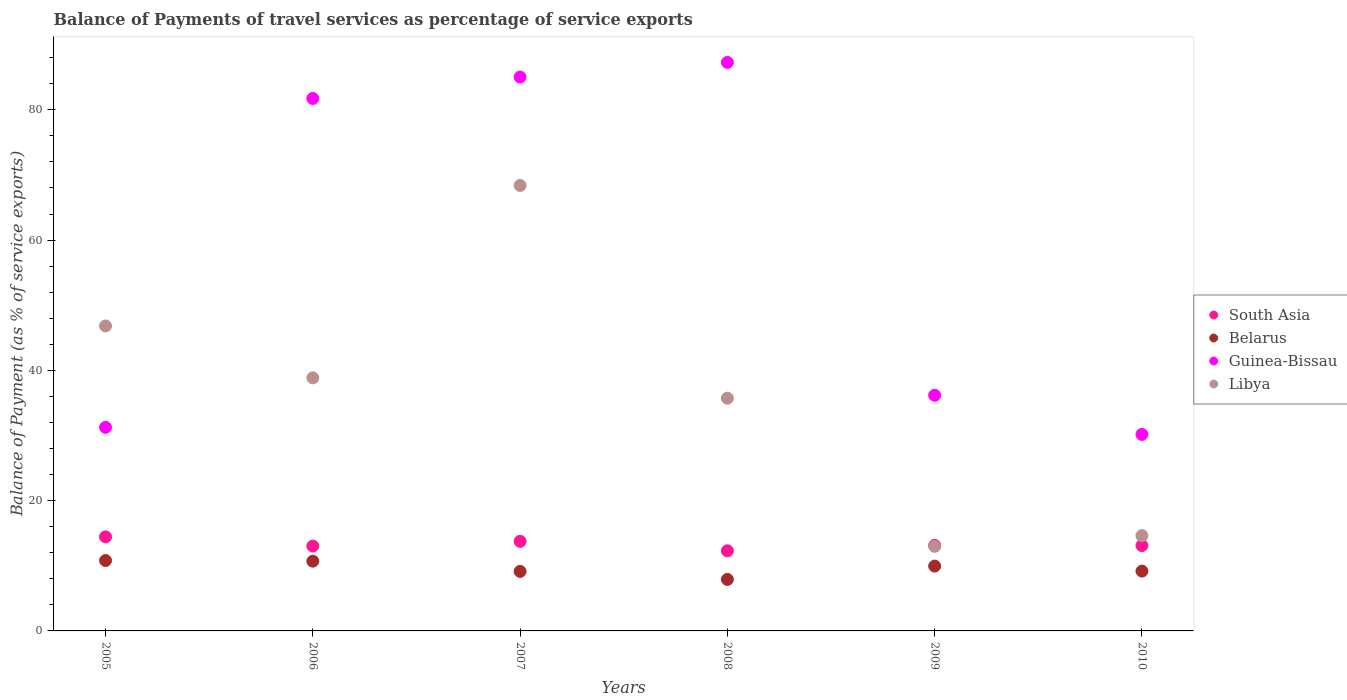What is the balance of payments of travel services in Guinea-Bissau in 2009?
Make the answer very short. 36.17. Across all years, what is the maximum balance of payments of travel services in Belarus?
Your answer should be very brief. 10.81. Across all years, what is the minimum balance of payments of travel services in Guinea-Bissau?
Ensure brevity in your answer.  30.17. In which year was the balance of payments of travel services in Libya minimum?
Ensure brevity in your answer.  2009. What is the total balance of payments of travel services in Libya in the graph?
Offer a terse response. 217.4. What is the difference between the balance of payments of travel services in Libya in 2007 and that in 2008?
Make the answer very short. 32.66. What is the difference between the balance of payments of travel services in South Asia in 2006 and the balance of payments of travel services in Belarus in 2008?
Provide a short and direct response. 5.12. What is the average balance of payments of travel services in Belarus per year?
Ensure brevity in your answer.  9.62. In the year 2006, what is the difference between the balance of payments of travel services in Libya and balance of payments of travel services in Belarus?
Your answer should be compact. 28.15. In how many years, is the balance of payments of travel services in South Asia greater than 44 %?
Your answer should be compact. 0. What is the ratio of the balance of payments of travel services in Libya in 2006 to that in 2009?
Offer a very short reply. 2.99. Is the difference between the balance of payments of travel services in Libya in 2007 and 2009 greater than the difference between the balance of payments of travel services in Belarus in 2007 and 2009?
Your response must be concise. Yes. What is the difference between the highest and the second highest balance of payments of travel services in Guinea-Bissau?
Offer a terse response. 2.25. What is the difference between the highest and the lowest balance of payments of travel services in South Asia?
Your answer should be compact. 2.14. Is the sum of the balance of payments of travel services in Libya in 2006 and 2010 greater than the maximum balance of payments of travel services in Belarus across all years?
Offer a very short reply. Yes. Is it the case that in every year, the sum of the balance of payments of travel services in Guinea-Bissau and balance of payments of travel services in South Asia  is greater than the sum of balance of payments of travel services in Libya and balance of payments of travel services in Belarus?
Provide a succinct answer. Yes. Is it the case that in every year, the sum of the balance of payments of travel services in Libya and balance of payments of travel services in South Asia  is greater than the balance of payments of travel services in Guinea-Bissau?
Your answer should be compact. No. Is the balance of payments of travel services in South Asia strictly less than the balance of payments of travel services in Belarus over the years?
Give a very brief answer. No. How many dotlines are there?
Make the answer very short. 4. How many years are there in the graph?
Make the answer very short. 6. Are the values on the major ticks of Y-axis written in scientific E-notation?
Offer a terse response. No. Does the graph contain any zero values?
Your answer should be compact. No. Does the graph contain grids?
Ensure brevity in your answer.  No. How many legend labels are there?
Offer a very short reply. 4. How are the legend labels stacked?
Your response must be concise. Vertical. What is the title of the graph?
Give a very brief answer. Balance of Payments of travel services as percentage of service exports. What is the label or title of the Y-axis?
Ensure brevity in your answer.  Balance of Payment (as % of service exports). What is the Balance of Payment (as % of service exports) of South Asia in 2005?
Provide a short and direct response. 14.44. What is the Balance of Payment (as % of service exports) of Belarus in 2005?
Offer a terse response. 10.81. What is the Balance of Payment (as % of service exports) in Guinea-Bissau in 2005?
Give a very brief answer. 31.25. What is the Balance of Payment (as % of service exports) of Libya in 2005?
Ensure brevity in your answer.  46.82. What is the Balance of Payment (as % of service exports) in South Asia in 2006?
Ensure brevity in your answer.  13.03. What is the Balance of Payment (as % of service exports) of Belarus in 2006?
Your response must be concise. 10.71. What is the Balance of Payment (as % of service exports) in Guinea-Bissau in 2006?
Provide a succinct answer. 81.74. What is the Balance of Payment (as % of service exports) of Libya in 2006?
Provide a short and direct response. 38.85. What is the Balance of Payment (as % of service exports) in South Asia in 2007?
Your answer should be very brief. 13.75. What is the Balance of Payment (as % of service exports) in Belarus in 2007?
Offer a terse response. 9.14. What is the Balance of Payment (as % of service exports) of Guinea-Bissau in 2007?
Make the answer very short. 85.03. What is the Balance of Payment (as % of service exports) in Libya in 2007?
Your answer should be compact. 68.39. What is the Balance of Payment (as % of service exports) of South Asia in 2008?
Provide a short and direct response. 12.3. What is the Balance of Payment (as % of service exports) of Belarus in 2008?
Offer a terse response. 7.91. What is the Balance of Payment (as % of service exports) of Guinea-Bissau in 2008?
Offer a very short reply. 87.27. What is the Balance of Payment (as % of service exports) of Libya in 2008?
Ensure brevity in your answer.  35.72. What is the Balance of Payment (as % of service exports) in South Asia in 2009?
Offer a very short reply. 13.14. What is the Balance of Payment (as % of service exports) in Belarus in 2009?
Your answer should be very brief. 9.95. What is the Balance of Payment (as % of service exports) of Guinea-Bissau in 2009?
Give a very brief answer. 36.17. What is the Balance of Payment (as % of service exports) of Libya in 2009?
Keep it short and to the point. 12.99. What is the Balance of Payment (as % of service exports) of South Asia in 2010?
Provide a succinct answer. 13.11. What is the Balance of Payment (as % of service exports) in Belarus in 2010?
Provide a short and direct response. 9.18. What is the Balance of Payment (as % of service exports) of Guinea-Bissau in 2010?
Ensure brevity in your answer.  30.17. What is the Balance of Payment (as % of service exports) of Libya in 2010?
Give a very brief answer. 14.63. Across all years, what is the maximum Balance of Payment (as % of service exports) in South Asia?
Make the answer very short. 14.44. Across all years, what is the maximum Balance of Payment (as % of service exports) in Belarus?
Make the answer very short. 10.81. Across all years, what is the maximum Balance of Payment (as % of service exports) of Guinea-Bissau?
Offer a very short reply. 87.27. Across all years, what is the maximum Balance of Payment (as % of service exports) of Libya?
Offer a terse response. 68.39. Across all years, what is the minimum Balance of Payment (as % of service exports) in South Asia?
Provide a short and direct response. 12.3. Across all years, what is the minimum Balance of Payment (as % of service exports) in Belarus?
Offer a terse response. 7.91. Across all years, what is the minimum Balance of Payment (as % of service exports) in Guinea-Bissau?
Offer a very short reply. 30.17. Across all years, what is the minimum Balance of Payment (as % of service exports) in Libya?
Ensure brevity in your answer.  12.99. What is the total Balance of Payment (as % of service exports) in South Asia in the graph?
Provide a succinct answer. 79.76. What is the total Balance of Payment (as % of service exports) of Belarus in the graph?
Offer a very short reply. 57.7. What is the total Balance of Payment (as % of service exports) of Guinea-Bissau in the graph?
Your answer should be very brief. 351.63. What is the total Balance of Payment (as % of service exports) of Libya in the graph?
Provide a succinct answer. 217.4. What is the difference between the Balance of Payment (as % of service exports) in South Asia in 2005 and that in 2006?
Your answer should be very brief. 1.41. What is the difference between the Balance of Payment (as % of service exports) of Belarus in 2005 and that in 2006?
Offer a terse response. 0.1. What is the difference between the Balance of Payment (as % of service exports) of Guinea-Bissau in 2005 and that in 2006?
Ensure brevity in your answer.  -50.49. What is the difference between the Balance of Payment (as % of service exports) of Libya in 2005 and that in 2006?
Your response must be concise. 7.96. What is the difference between the Balance of Payment (as % of service exports) of South Asia in 2005 and that in 2007?
Offer a very short reply. 0.69. What is the difference between the Balance of Payment (as % of service exports) of Belarus in 2005 and that in 2007?
Give a very brief answer. 1.67. What is the difference between the Balance of Payment (as % of service exports) in Guinea-Bissau in 2005 and that in 2007?
Provide a succinct answer. -53.77. What is the difference between the Balance of Payment (as % of service exports) of Libya in 2005 and that in 2007?
Offer a terse response. -21.57. What is the difference between the Balance of Payment (as % of service exports) in South Asia in 2005 and that in 2008?
Offer a very short reply. 2.14. What is the difference between the Balance of Payment (as % of service exports) in Belarus in 2005 and that in 2008?
Give a very brief answer. 2.9. What is the difference between the Balance of Payment (as % of service exports) in Guinea-Bissau in 2005 and that in 2008?
Give a very brief answer. -56.02. What is the difference between the Balance of Payment (as % of service exports) of Libya in 2005 and that in 2008?
Make the answer very short. 11.09. What is the difference between the Balance of Payment (as % of service exports) in South Asia in 2005 and that in 2009?
Make the answer very short. 1.3. What is the difference between the Balance of Payment (as % of service exports) in Belarus in 2005 and that in 2009?
Ensure brevity in your answer.  0.85. What is the difference between the Balance of Payment (as % of service exports) of Guinea-Bissau in 2005 and that in 2009?
Ensure brevity in your answer.  -4.92. What is the difference between the Balance of Payment (as % of service exports) in Libya in 2005 and that in 2009?
Your response must be concise. 33.83. What is the difference between the Balance of Payment (as % of service exports) of South Asia in 2005 and that in 2010?
Offer a terse response. 1.33. What is the difference between the Balance of Payment (as % of service exports) of Belarus in 2005 and that in 2010?
Your response must be concise. 1.62. What is the difference between the Balance of Payment (as % of service exports) in Guinea-Bissau in 2005 and that in 2010?
Ensure brevity in your answer.  1.09. What is the difference between the Balance of Payment (as % of service exports) in Libya in 2005 and that in 2010?
Ensure brevity in your answer.  32.19. What is the difference between the Balance of Payment (as % of service exports) of South Asia in 2006 and that in 2007?
Your answer should be compact. -0.72. What is the difference between the Balance of Payment (as % of service exports) in Belarus in 2006 and that in 2007?
Offer a terse response. 1.57. What is the difference between the Balance of Payment (as % of service exports) of Guinea-Bissau in 2006 and that in 2007?
Give a very brief answer. -3.28. What is the difference between the Balance of Payment (as % of service exports) of Libya in 2006 and that in 2007?
Your answer should be compact. -29.53. What is the difference between the Balance of Payment (as % of service exports) in South Asia in 2006 and that in 2008?
Your answer should be compact. 0.73. What is the difference between the Balance of Payment (as % of service exports) of Belarus in 2006 and that in 2008?
Your answer should be very brief. 2.8. What is the difference between the Balance of Payment (as % of service exports) of Guinea-Bissau in 2006 and that in 2008?
Make the answer very short. -5.53. What is the difference between the Balance of Payment (as % of service exports) in Libya in 2006 and that in 2008?
Offer a very short reply. 3.13. What is the difference between the Balance of Payment (as % of service exports) of South Asia in 2006 and that in 2009?
Give a very brief answer. -0.11. What is the difference between the Balance of Payment (as % of service exports) of Belarus in 2006 and that in 2009?
Ensure brevity in your answer.  0.75. What is the difference between the Balance of Payment (as % of service exports) in Guinea-Bissau in 2006 and that in 2009?
Your answer should be very brief. 45.57. What is the difference between the Balance of Payment (as % of service exports) in Libya in 2006 and that in 2009?
Your answer should be compact. 25.87. What is the difference between the Balance of Payment (as % of service exports) of South Asia in 2006 and that in 2010?
Offer a very short reply. -0.08. What is the difference between the Balance of Payment (as % of service exports) of Belarus in 2006 and that in 2010?
Keep it short and to the point. 1.53. What is the difference between the Balance of Payment (as % of service exports) of Guinea-Bissau in 2006 and that in 2010?
Offer a terse response. 51.58. What is the difference between the Balance of Payment (as % of service exports) of Libya in 2006 and that in 2010?
Your answer should be very brief. 24.22. What is the difference between the Balance of Payment (as % of service exports) of South Asia in 2007 and that in 2008?
Provide a short and direct response. 1.45. What is the difference between the Balance of Payment (as % of service exports) in Belarus in 2007 and that in 2008?
Make the answer very short. 1.23. What is the difference between the Balance of Payment (as % of service exports) of Guinea-Bissau in 2007 and that in 2008?
Ensure brevity in your answer.  -2.25. What is the difference between the Balance of Payment (as % of service exports) of Libya in 2007 and that in 2008?
Your answer should be very brief. 32.66. What is the difference between the Balance of Payment (as % of service exports) in South Asia in 2007 and that in 2009?
Keep it short and to the point. 0.61. What is the difference between the Balance of Payment (as % of service exports) of Belarus in 2007 and that in 2009?
Your response must be concise. -0.82. What is the difference between the Balance of Payment (as % of service exports) of Guinea-Bissau in 2007 and that in 2009?
Your response must be concise. 48.85. What is the difference between the Balance of Payment (as % of service exports) in Libya in 2007 and that in 2009?
Your answer should be compact. 55.4. What is the difference between the Balance of Payment (as % of service exports) in South Asia in 2007 and that in 2010?
Provide a succinct answer. 0.64. What is the difference between the Balance of Payment (as % of service exports) in Belarus in 2007 and that in 2010?
Your response must be concise. -0.05. What is the difference between the Balance of Payment (as % of service exports) in Guinea-Bissau in 2007 and that in 2010?
Offer a terse response. 54.86. What is the difference between the Balance of Payment (as % of service exports) of Libya in 2007 and that in 2010?
Ensure brevity in your answer.  53.76. What is the difference between the Balance of Payment (as % of service exports) in South Asia in 2008 and that in 2009?
Your answer should be compact. -0.84. What is the difference between the Balance of Payment (as % of service exports) of Belarus in 2008 and that in 2009?
Your response must be concise. -2.05. What is the difference between the Balance of Payment (as % of service exports) in Guinea-Bissau in 2008 and that in 2009?
Your response must be concise. 51.1. What is the difference between the Balance of Payment (as % of service exports) of Libya in 2008 and that in 2009?
Make the answer very short. 22.74. What is the difference between the Balance of Payment (as % of service exports) of South Asia in 2008 and that in 2010?
Your response must be concise. -0.81. What is the difference between the Balance of Payment (as % of service exports) of Belarus in 2008 and that in 2010?
Offer a very short reply. -1.28. What is the difference between the Balance of Payment (as % of service exports) of Guinea-Bissau in 2008 and that in 2010?
Provide a short and direct response. 57.11. What is the difference between the Balance of Payment (as % of service exports) in Libya in 2008 and that in 2010?
Keep it short and to the point. 21.09. What is the difference between the Balance of Payment (as % of service exports) of South Asia in 2009 and that in 2010?
Offer a terse response. 0.04. What is the difference between the Balance of Payment (as % of service exports) in Belarus in 2009 and that in 2010?
Offer a very short reply. 0.77. What is the difference between the Balance of Payment (as % of service exports) of Guinea-Bissau in 2009 and that in 2010?
Ensure brevity in your answer.  6.01. What is the difference between the Balance of Payment (as % of service exports) of Libya in 2009 and that in 2010?
Your response must be concise. -1.64. What is the difference between the Balance of Payment (as % of service exports) of South Asia in 2005 and the Balance of Payment (as % of service exports) of Belarus in 2006?
Your answer should be compact. 3.73. What is the difference between the Balance of Payment (as % of service exports) in South Asia in 2005 and the Balance of Payment (as % of service exports) in Guinea-Bissau in 2006?
Your answer should be compact. -67.3. What is the difference between the Balance of Payment (as % of service exports) of South Asia in 2005 and the Balance of Payment (as % of service exports) of Libya in 2006?
Provide a short and direct response. -24.42. What is the difference between the Balance of Payment (as % of service exports) in Belarus in 2005 and the Balance of Payment (as % of service exports) in Guinea-Bissau in 2006?
Offer a very short reply. -70.94. What is the difference between the Balance of Payment (as % of service exports) in Belarus in 2005 and the Balance of Payment (as % of service exports) in Libya in 2006?
Offer a very short reply. -28.05. What is the difference between the Balance of Payment (as % of service exports) of Guinea-Bissau in 2005 and the Balance of Payment (as % of service exports) of Libya in 2006?
Offer a terse response. -7.6. What is the difference between the Balance of Payment (as % of service exports) of South Asia in 2005 and the Balance of Payment (as % of service exports) of Belarus in 2007?
Provide a succinct answer. 5.3. What is the difference between the Balance of Payment (as % of service exports) of South Asia in 2005 and the Balance of Payment (as % of service exports) of Guinea-Bissau in 2007?
Make the answer very short. -70.59. What is the difference between the Balance of Payment (as % of service exports) of South Asia in 2005 and the Balance of Payment (as % of service exports) of Libya in 2007?
Offer a terse response. -53.95. What is the difference between the Balance of Payment (as % of service exports) in Belarus in 2005 and the Balance of Payment (as % of service exports) in Guinea-Bissau in 2007?
Offer a terse response. -74.22. What is the difference between the Balance of Payment (as % of service exports) in Belarus in 2005 and the Balance of Payment (as % of service exports) in Libya in 2007?
Keep it short and to the point. -57.58. What is the difference between the Balance of Payment (as % of service exports) in Guinea-Bissau in 2005 and the Balance of Payment (as % of service exports) in Libya in 2007?
Provide a short and direct response. -37.13. What is the difference between the Balance of Payment (as % of service exports) in South Asia in 2005 and the Balance of Payment (as % of service exports) in Belarus in 2008?
Offer a terse response. 6.53. What is the difference between the Balance of Payment (as % of service exports) in South Asia in 2005 and the Balance of Payment (as % of service exports) in Guinea-Bissau in 2008?
Offer a terse response. -72.84. What is the difference between the Balance of Payment (as % of service exports) of South Asia in 2005 and the Balance of Payment (as % of service exports) of Libya in 2008?
Offer a terse response. -21.29. What is the difference between the Balance of Payment (as % of service exports) of Belarus in 2005 and the Balance of Payment (as % of service exports) of Guinea-Bissau in 2008?
Your answer should be very brief. -76.47. What is the difference between the Balance of Payment (as % of service exports) in Belarus in 2005 and the Balance of Payment (as % of service exports) in Libya in 2008?
Offer a terse response. -24.92. What is the difference between the Balance of Payment (as % of service exports) of Guinea-Bissau in 2005 and the Balance of Payment (as % of service exports) of Libya in 2008?
Provide a short and direct response. -4.47. What is the difference between the Balance of Payment (as % of service exports) of South Asia in 2005 and the Balance of Payment (as % of service exports) of Belarus in 2009?
Keep it short and to the point. 4.48. What is the difference between the Balance of Payment (as % of service exports) in South Asia in 2005 and the Balance of Payment (as % of service exports) in Guinea-Bissau in 2009?
Your response must be concise. -21.73. What is the difference between the Balance of Payment (as % of service exports) in South Asia in 2005 and the Balance of Payment (as % of service exports) in Libya in 2009?
Offer a very short reply. 1.45. What is the difference between the Balance of Payment (as % of service exports) in Belarus in 2005 and the Balance of Payment (as % of service exports) in Guinea-Bissau in 2009?
Your response must be concise. -25.37. What is the difference between the Balance of Payment (as % of service exports) of Belarus in 2005 and the Balance of Payment (as % of service exports) of Libya in 2009?
Give a very brief answer. -2.18. What is the difference between the Balance of Payment (as % of service exports) of Guinea-Bissau in 2005 and the Balance of Payment (as % of service exports) of Libya in 2009?
Provide a succinct answer. 18.27. What is the difference between the Balance of Payment (as % of service exports) in South Asia in 2005 and the Balance of Payment (as % of service exports) in Belarus in 2010?
Offer a terse response. 5.25. What is the difference between the Balance of Payment (as % of service exports) in South Asia in 2005 and the Balance of Payment (as % of service exports) in Guinea-Bissau in 2010?
Give a very brief answer. -15.73. What is the difference between the Balance of Payment (as % of service exports) in South Asia in 2005 and the Balance of Payment (as % of service exports) in Libya in 2010?
Provide a short and direct response. -0.19. What is the difference between the Balance of Payment (as % of service exports) in Belarus in 2005 and the Balance of Payment (as % of service exports) in Guinea-Bissau in 2010?
Give a very brief answer. -19.36. What is the difference between the Balance of Payment (as % of service exports) of Belarus in 2005 and the Balance of Payment (as % of service exports) of Libya in 2010?
Your response must be concise. -3.83. What is the difference between the Balance of Payment (as % of service exports) in Guinea-Bissau in 2005 and the Balance of Payment (as % of service exports) in Libya in 2010?
Provide a succinct answer. 16.62. What is the difference between the Balance of Payment (as % of service exports) in South Asia in 2006 and the Balance of Payment (as % of service exports) in Belarus in 2007?
Your answer should be very brief. 3.89. What is the difference between the Balance of Payment (as % of service exports) in South Asia in 2006 and the Balance of Payment (as % of service exports) in Guinea-Bissau in 2007?
Offer a terse response. -72. What is the difference between the Balance of Payment (as % of service exports) of South Asia in 2006 and the Balance of Payment (as % of service exports) of Libya in 2007?
Offer a terse response. -55.36. What is the difference between the Balance of Payment (as % of service exports) in Belarus in 2006 and the Balance of Payment (as % of service exports) in Guinea-Bissau in 2007?
Offer a very short reply. -74.32. What is the difference between the Balance of Payment (as % of service exports) in Belarus in 2006 and the Balance of Payment (as % of service exports) in Libya in 2007?
Offer a very short reply. -57.68. What is the difference between the Balance of Payment (as % of service exports) in Guinea-Bissau in 2006 and the Balance of Payment (as % of service exports) in Libya in 2007?
Provide a short and direct response. 13.35. What is the difference between the Balance of Payment (as % of service exports) in South Asia in 2006 and the Balance of Payment (as % of service exports) in Belarus in 2008?
Make the answer very short. 5.12. What is the difference between the Balance of Payment (as % of service exports) in South Asia in 2006 and the Balance of Payment (as % of service exports) in Guinea-Bissau in 2008?
Make the answer very short. -74.25. What is the difference between the Balance of Payment (as % of service exports) of South Asia in 2006 and the Balance of Payment (as % of service exports) of Libya in 2008?
Provide a succinct answer. -22.7. What is the difference between the Balance of Payment (as % of service exports) of Belarus in 2006 and the Balance of Payment (as % of service exports) of Guinea-Bissau in 2008?
Ensure brevity in your answer.  -76.57. What is the difference between the Balance of Payment (as % of service exports) of Belarus in 2006 and the Balance of Payment (as % of service exports) of Libya in 2008?
Keep it short and to the point. -25.02. What is the difference between the Balance of Payment (as % of service exports) in Guinea-Bissau in 2006 and the Balance of Payment (as % of service exports) in Libya in 2008?
Offer a terse response. 46.02. What is the difference between the Balance of Payment (as % of service exports) of South Asia in 2006 and the Balance of Payment (as % of service exports) of Belarus in 2009?
Your answer should be compact. 3.07. What is the difference between the Balance of Payment (as % of service exports) in South Asia in 2006 and the Balance of Payment (as % of service exports) in Guinea-Bissau in 2009?
Your answer should be compact. -23.14. What is the difference between the Balance of Payment (as % of service exports) in South Asia in 2006 and the Balance of Payment (as % of service exports) in Libya in 2009?
Keep it short and to the point. 0.04. What is the difference between the Balance of Payment (as % of service exports) of Belarus in 2006 and the Balance of Payment (as % of service exports) of Guinea-Bissau in 2009?
Keep it short and to the point. -25.46. What is the difference between the Balance of Payment (as % of service exports) of Belarus in 2006 and the Balance of Payment (as % of service exports) of Libya in 2009?
Your answer should be very brief. -2.28. What is the difference between the Balance of Payment (as % of service exports) in Guinea-Bissau in 2006 and the Balance of Payment (as % of service exports) in Libya in 2009?
Your response must be concise. 68.75. What is the difference between the Balance of Payment (as % of service exports) of South Asia in 2006 and the Balance of Payment (as % of service exports) of Belarus in 2010?
Your answer should be very brief. 3.84. What is the difference between the Balance of Payment (as % of service exports) of South Asia in 2006 and the Balance of Payment (as % of service exports) of Guinea-Bissau in 2010?
Your answer should be compact. -17.14. What is the difference between the Balance of Payment (as % of service exports) of South Asia in 2006 and the Balance of Payment (as % of service exports) of Libya in 2010?
Give a very brief answer. -1.6. What is the difference between the Balance of Payment (as % of service exports) in Belarus in 2006 and the Balance of Payment (as % of service exports) in Guinea-Bissau in 2010?
Make the answer very short. -19.46. What is the difference between the Balance of Payment (as % of service exports) of Belarus in 2006 and the Balance of Payment (as % of service exports) of Libya in 2010?
Your answer should be compact. -3.92. What is the difference between the Balance of Payment (as % of service exports) of Guinea-Bissau in 2006 and the Balance of Payment (as % of service exports) of Libya in 2010?
Your answer should be compact. 67.11. What is the difference between the Balance of Payment (as % of service exports) of South Asia in 2007 and the Balance of Payment (as % of service exports) of Belarus in 2008?
Your response must be concise. 5.84. What is the difference between the Balance of Payment (as % of service exports) in South Asia in 2007 and the Balance of Payment (as % of service exports) in Guinea-Bissau in 2008?
Offer a very short reply. -73.52. What is the difference between the Balance of Payment (as % of service exports) of South Asia in 2007 and the Balance of Payment (as % of service exports) of Libya in 2008?
Give a very brief answer. -21.97. What is the difference between the Balance of Payment (as % of service exports) in Belarus in 2007 and the Balance of Payment (as % of service exports) in Guinea-Bissau in 2008?
Your answer should be compact. -78.14. What is the difference between the Balance of Payment (as % of service exports) in Belarus in 2007 and the Balance of Payment (as % of service exports) in Libya in 2008?
Ensure brevity in your answer.  -26.59. What is the difference between the Balance of Payment (as % of service exports) in Guinea-Bissau in 2007 and the Balance of Payment (as % of service exports) in Libya in 2008?
Offer a terse response. 49.3. What is the difference between the Balance of Payment (as % of service exports) in South Asia in 2007 and the Balance of Payment (as % of service exports) in Belarus in 2009?
Provide a short and direct response. 3.8. What is the difference between the Balance of Payment (as % of service exports) in South Asia in 2007 and the Balance of Payment (as % of service exports) in Guinea-Bissau in 2009?
Your response must be concise. -22.42. What is the difference between the Balance of Payment (as % of service exports) of South Asia in 2007 and the Balance of Payment (as % of service exports) of Libya in 2009?
Offer a terse response. 0.76. What is the difference between the Balance of Payment (as % of service exports) of Belarus in 2007 and the Balance of Payment (as % of service exports) of Guinea-Bissau in 2009?
Your answer should be compact. -27.03. What is the difference between the Balance of Payment (as % of service exports) of Belarus in 2007 and the Balance of Payment (as % of service exports) of Libya in 2009?
Give a very brief answer. -3.85. What is the difference between the Balance of Payment (as % of service exports) in Guinea-Bissau in 2007 and the Balance of Payment (as % of service exports) in Libya in 2009?
Your response must be concise. 72.04. What is the difference between the Balance of Payment (as % of service exports) in South Asia in 2007 and the Balance of Payment (as % of service exports) in Belarus in 2010?
Make the answer very short. 4.57. What is the difference between the Balance of Payment (as % of service exports) in South Asia in 2007 and the Balance of Payment (as % of service exports) in Guinea-Bissau in 2010?
Your response must be concise. -16.42. What is the difference between the Balance of Payment (as % of service exports) in South Asia in 2007 and the Balance of Payment (as % of service exports) in Libya in 2010?
Your answer should be very brief. -0.88. What is the difference between the Balance of Payment (as % of service exports) in Belarus in 2007 and the Balance of Payment (as % of service exports) in Guinea-Bissau in 2010?
Give a very brief answer. -21.03. What is the difference between the Balance of Payment (as % of service exports) of Belarus in 2007 and the Balance of Payment (as % of service exports) of Libya in 2010?
Provide a short and direct response. -5.49. What is the difference between the Balance of Payment (as % of service exports) in Guinea-Bissau in 2007 and the Balance of Payment (as % of service exports) in Libya in 2010?
Your response must be concise. 70.39. What is the difference between the Balance of Payment (as % of service exports) in South Asia in 2008 and the Balance of Payment (as % of service exports) in Belarus in 2009?
Make the answer very short. 2.35. What is the difference between the Balance of Payment (as % of service exports) of South Asia in 2008 and the Balance of Payment (as % of service exports) of Guinea-Bissau in 2009?
Your answer should be very brief. -23.87. What is the difference between the Balance of Payment (as % of service exports) of South Asia in 2008 and the Balance of Payment (as % of service exports) of Libya in 2009?
Provide a succinct answer. -0.69. What is the difference between the Balance of Payment (as % of service exports) of Belarus in 2008 and the Balance of Payment (as % of service exports) of Guinea-Bissau in 2009?
Offer a very short reply. -28.26. What is the difference between the Balance of Payment (as % of service exports) in Belarus in 2008 and the Balance of Payment (as % of service exports) in Libya in 2009?
Give a very brief answer. -5.08. What is the difference between the Balance of Payment (as % of service exports) of Guinea-Bissau in 2008 and the Balance of Payment (as % of service exports) of Libya in 2009?
Make the answer very short. 74.29. What is the difference between the Balance of Payment (as % of service exports) in South Asia in 2008 and the Balance of Payment (as % of service exports) in Belarus in 2010?
Your answer should be very brief. 3.12. What is the difference between the Balance of Payment (as % of service exports) in South Asia in 2008 and the Balance of Payment (as % of service exports) in Guinea-Bissau in 2010?
Make the answer very short. -17.87. What is the difference between the Balance of Payment (as % of service exports) in South Asia in 2008 and the Balance of Payment (as % of service exports) in Libya in 2010?
Give a very brief answer. -2.33. What is the difference between the Balance of Payment (as % of service exports) in Belarus in 2008 and the Balance of Payment (as % of service exports) in Guinea-Bissau in 2010?
Make the answer very short. -22.26. What is the difference between the Balance of Payment (as % of service exports) of Belarus in 2008 and the Balance of Payment (as % of service exports) of Libya in 2010?
Offer a terse response. -6.72. What is the difference between the Balance of Payment (as % of service exports) of Guinea-Bissau in 2008 and the Balance of Payment (as % of service exports) of Libya in 2010?
Offer a terse response. 72.64. What is the difference between the Balance of Payment (as % of service exports) in South Asia in 2009 and the Balance of Payment (as % of service exports) in Belarus in 2010?
Your answer should be compact. 3.96. What is the difference between the Balance of Payment (as % of service exports) of South Asia in 2009 and the Balance of Payment (as % of service exports) of Guinea-Bissau in 2010?
Make the answer very short. -17.02. What is the difference between the Balance of Payment (as % of service exports) of South Asia in 2009 and the Balance of Payment (as % of service exports) of Libya in 2010?
Your answer should be compact. -1.49. What is the difference between the Balance of Payment (as % of service exports) in Belarus in 2009 and the Balance of Payment (as % of service exports) in Guinea-Bissau in 2010?
Offer a very short reply. -20.21. What is the difference between the Balance of Payment (as % of service exports) of Belarus in 2009 and the Balance of Payment (as % of service exports) of Libya in 2010?
Your response must be concise. -4.68. What is the difference between the Balance of Payment (as % of service exports) of Guinea-Bissau in 2009 and the Balance of Payment (as % of service exports) of Libya in 2010?
Offer a very short reply. 21.54. What is the average Balance of Payment (as % of service exports) in South Asia per year?
Your answer should be very brief. 13.29. What is the average Balance of Payment (as % of service exports) in Belarus per year?
Provide a succinct answer. 9.62. What is the average Balance of Payment (as % of service exports) in Guinea-Bissau per year?
Your answer should be compact. 58.61. What is the average Balance of Payment (as % of service exports) of Libya per year?
Your response must be concise. 36.23. In the year 2005, what is the difference between the Balance of Payment (as % of service exports) in South Asia and Balance of Payment (as % of service exports) in Belarus?
Your response must be concise. 3.63. In the year 2005, what is the difference between the Balance of Payment (as % of service exports) of South Asia and Balance of Payment (as % of service exports) of Guinea-Bissau?
Give a very brief answer. -16.82. In the year 2005, what is the difference between the Balance of Payment (as % of service exports) in South Asia and Balance of Payment (as % of service exports) in Libya?
Keep it short and to the point. -32.38. In the year 2005, what is the difference between the Balance of Payment (as % of service exports) of Belarus and Balance of Payment (as % of service exports) of Guinea-Bissau?
Ensure brevity in your answer.  -20.45. In the year 2005, what is the difference between the Balance of Payment (as % of service exports) of Belarus and Balance of Payment (as % of service exports) of Libya?
Offer a terse response. -36.01. In the year 2005, what is the difference between the Balance of Payment (as % of service exports) of Guinea-Bissau and Balance of Payment (as % of service exports) of Libya?
Provide a short and direct response. -15.56. In the year 2006, what is the difference between the Balance of Payment (as % of service exports) in South Asia and Balance of Payment (as % of service exports) in Belarus?
Give a very brief answer. 2.32. In the year 2006, what is the difference between the Balance of Payment (as % of service exports) of South Asia and Balance of Payment (as % of service exports) of Guinea-Bissau?
Your answer should be very brief. -68.71. In the year 2006, what is the difference between the Balance of Payment (as % of service exports) of South Asia and Balance of Payment (as % of service exports) of Libya?
Make the answer very short. -25.83. In the year 2006, what is the difference between the Balance of Payment (as % of service exports) in Belarus and Balance of Payment (as % of service exports) in Guinea-Bissau?
Your answer should be compact. -71.03. In the year 2006, what is the difference between the Balance of Payment (as % of service exports) of Belarus and Balance of Payment (as % of service exports) of Libya?
Give a very brief answer. -28.15. In the year 2006, what is the difference between the Balance of Payment (as % of service exports) in Guinea-Bissau and Balance of Payment (as % of service exports) in Libya?
Offer a terse response. 42.89. In the year 2007, what is the difference between the Balance of Payment (as % of service exports) in South Asia and Balance of Payment (as % of service exports) in Belarus?
Give a very brief answer. 4.61. In the year 2007, what is the difference between the Balance of Payment (as % of service exports) in South Asia and Balance of Payment (as % of service exports) in Guinea-Bissau?
Provide a short and direct response. -71.28. In the year 2007, what is the difference between the Balance of Payment (as % of service exports) of South Asia and Balance of Payment (as % of service exports) of Libya?
Your response must be concise. -54.64. In the year 2007, what is the difference between the Balance of Payment (as % of service exports) in Belarus and Balance of Payment (as % of service exports) in Guinea-Bissau?
Your answer should be very brief. -75.89. In the year 2007, what is the difference between the Balance of Payment (as % of service exports) of Belarus and Balance of Payment (as % of service exports) of Libya?
Offer a terse response. -59.25. In the year 2007, what is the difference between the Balance of Payment (as % of service exports) of Guinea-Bissau and Balance of Payment (as % of service exports) of Libya?
Your response must be concise. 16.64. In the year 2008, what is the difference between the Balance of Payment (as % of service exports) of South Asia and Balance of Payment (as % of service exports) of Belarus?
Your answer should be compact. 4.39. In the year 2008, what is the difference between the Balance of Payment (as % of service exports) of South Asia and Balance of Payment (as % of service exports) of Guinea-Bissau?
Make the answer very short. -74.97. In the year 2008, what is the difference between the Balance of Payment (as % of service exports) of South Asia and Balance of Payment (as % of service exports) of Libya?
Provide a succinct answer. -23.42. In the year 2008, what is the difference between the Balance of Payment (as % of service exports) of Belarus and Balance of Payment (as % of service exports) of Guinea-Bissau?
Make the answer very short. -79.37. In the year 2008, what is the difference between the Balance of Payment (as % of service exports) in Belarus and Balance of Payment (as % of service exports) in Libya?
Your answer should be compact. -27.82. In the year 2008, what is the difference between the Balance of Payment (as % of service exports) in Guinea-Bissau and Balance of Payment (as % of service exports) in Libya?
Make the answer very short. 51.55. In the year 2009, what is the difference between the Balance of Payment (as % of service exports) of South Asia and Balance of Payment (as % of service exports) of Belarus?
Your answer should be very brief. 3.19. In the year 2009, what is the difference between the Balance of Payment (as % of service exports) of South Asia and Balance of Payment (as % of service exports) of Guinea-Bissau?
Your response must be concise. -23.03. In the year 2009, what is the difference between the Balance of Payment (as % of service exports) in South Asia and Balance of Payment (as % of service exports) in Libya?
Provide a succinct answer. 0.15. In the year 2009, what is the difference between the Balance of Payment (as % of service exports) of Belarus and Balance of Payment (as % of service exports) of Guinea-Bissau?
Ensure brevity in your answer.  -26.22. In the year 2009, what is the difference between the Balance of Payment (as % of service exports) in Belarus and Balance of Payment (as % of service exports) in Libya?
Offer a terse response. -3.03. In the year 2009, what is the difference between the Balance of Payment (as % of service exports) in Guinea-Bissau and Balance of Payment (as % of service exports) in Libya?
Your answer should be compact. 23.18. In the year 2010, what is the difference between the Balance of Payment (as % of service exports) of South Asia and Balance of Payment (as % of service exports) of Belarus?
Keep it short and to the point. 3.92. In the year 2010, what is the difference between the Balance of Payment (as % of service exports) in South Asia and Balance of Payment (as % of service exports) in Guinea-Bissau?
Provide a short and direct response. -17.06. In the year 2010, what is the difference between the Balance of Payment (as % of service exports) of South Asia and Balance of Payment (as % of service exports) of Libya?
Make the answer very short. -1.52. In the year 2010, what is the difference between the Balance of Payment (as % of service exports) in Belarus and Balance of Payment (as % of service exports) in Guinea-Bissau?
Your response must be concise. -20.98. In the year 2010, what is the difference between the Balance of Payment (as % of service exports) of Belarus and Balance of Payment (as % of service exports) of Libya?
Give a very brief answer. -5.45. In the year 2010, what is the difference between the Balance of Payment (as % of service exports) of Guinea-Bissau and Balance of Payment (as % of service exports) of Libya?
Keep it short and to the point. 15.54. What is the ratio of the Balance of Payment (as % of service exports) in South Asia in 2005 to that in 2006?
Ensure brevity in your answer.  1.11. What is the ratio of the Balance of Payment (as % of service exports) of Belarus in 2005 to that in 2006?
Your response must be concise. 1.01. What is the ratio of the Balance of Payment (as % of service exports) of Guinea-Bissau in 2005 to that in 2006?
Provide a short and direct response. 0.38. What is the ratio of the Balance of Payment (as % of service exports) of Libya in 2005 to that in 2006?
Your answer should be compact. 1.2. What is the ratio of the Balance of Payment (as % of service exports) of South Asia in 2005 to that in 2007?
Offer a terse response. 1.05. What is the ratio of the Balance of Payment (as % of service exports) of Belarus in 2005 to that in 2007?
Provide a succinct answer. 1.18. What is the ratio of the Balance of Payment (as % of service exports) of Guinea-Bissau in 2005 to that in 2007?
Provide a succinct answer. 0.37. What is the ratio of the Balance of Payment (as % of service exports) of Libya in 2005 to that in 2007?
Offer a terse response. 0.68. What is the ratio of the Balance of Payment (as % of service exports) of South Asia in 2005 to that in 2008?
Give a very brief answer. 1.17. What is the ratio of the Balance of Payment (as % of service exports) of Belarus in 2005 to that in 2008?
Give a very brief answer. 1.37. What is the ratio of the Balance of Payment (as % of service exports) of Guinea-Bissau in 2005 to that in 2008?
Offer a very short reply. 0.36. What is the ratio of the Balance of Payment (as % of service exports) in Libya in 2005 to that in 2008?
Ensure brevity in your answer.  1.31. What is the ratio of the Balance of Payment (as % of service exports) of South Asia in 2005 to that in 2009?
Provide a succinct answer. 1.1. What is the ratio of the Balance of Payment (as % of service exports) in Belarus in 2005 to that in 2009?
Your answer should be very brief. 1.09. What is the ratio of the Balance of Payment (as % of service exports) in Guinea-Bissau in 2005 to that in 2009?
Offer a very short reply. 0.86. What is the ratio of the Balance of Payment (as % of service exports) in Libya in 2005 to that in 2009?
Provide a succinct answer. 3.6. What is the ratio of the Balance of Payment (as % of service exports) in South Asia in 2005 to that in 2010?
Ensure brevity in your answer.  1.1. What is the ratio of the Balance of Payment (as % of service exports) in Belarus in 2005 to that in 2010?
Provide a short and direct response. 1.18. What is the ratio of the Balance of Payment (as % of service exports) of Guinea-Bissau in 2005 to that in 2010?
Make the answer very short. 1.04. What is the ratio of the Balance of Payment (as % of service exports) in Libya in 2005 to that in 2010?
Ensure brevity in your answer.  3.2. What is the ratio of the Balance of Payment (as % of service exports) in South Asia in 2006 to that in 2007?
Your response must be concise. 0.95. What is the ratio of the Balance of Payment (as % of service exports) of Belarus in 2006 to that in 2007?
Your answer should be compact. 1.17. What is the ratio of the Balance of Payment (as % of service exports) of Guinea-Bissau in 2006 to that in 2007?
Provide a succinct answer. 0.96. What is the ratio of the Balance of Payment (as % of service exports) of Libya in 2006 to that in 2007?
Provide a short and direct response. 0.57. What is the ratio of the Balance of Payment (as % of service exports) of South Asia in 2006 to that in 2008?
Make the answer very short. 1.06. What is the ratio of the Balance of Payment (as % of service exports) of Belarus in 2006 to that in 2008?
Your answer should be compact. 1.35. What is the ratio of the Balance of Payment (as % of service exports) of Guinea-Bissau in 2006 to that in 2008?
Offer a terse response. 0.94. What is the ratio of the Balance of Payment (as % of service exports) in Libya in 2006 to that in 2008?
Offer a very short reply. 1.09. What is the ratio of the Balance of Payment (as % of service exports) of South Asia in 2006 to that in 2009?
Ensure brevity in your answer.  0.99. What is the ratio of the Balance of Payment (as % of service exports) of Belarus in 2006 to that in 2009?
Keep it short and to the point. 1.08. What is the ratio of the Balance of Payment (as % of service exports) in Guinea-Bissau in 2006 to that in 2009?
Make the answer very short. 2.26. What is the ratio of the Balance of Payment (as % of service exports) in Libya in 2006 to that in 2009?
Offer a terse response. 2.99. What is the ratio of the Balance of Payment (as % of service exports) of South Asia in 2006 to that in 2010?
Provide a short and direct response. 0.99. What is the ratio of the Balance of Payment (as % of service exports) of Belarus in 2006 to that in 2010?
Your answer should be very brief. 1.17. What is the ratio of the Balance of Payment (as % of service exports) in Guinea-Bissau in 2006 to that in 2010?
Give a very brief answer. 2.71. What is the ratio of the Balance of Payment (as % of service exports) in Libya in 2006 to that in 2010?
Ensure brevity in your answer.  2.66. What is the ratio of the Balance of Payment (as % of service exports) of South Asia in 2007 to that in 2008?
Your response must be concise. 1.12. What is the ratio of the Balance of Payment (as % of service exports) in Belarus in 2007 to that in 2008?
Keep it short and to the point. 1.16. What is the ratio of the Balance of Payment (as % of service exports) of Guinea-Bissau in 2007 to that in 2008?
Ensure brevity in your answer.  0.97. What is the ratio of the Balance of Payment (as % of service exports) in Libya in 2007 to that in 2008?
Offer a terse response. 1.91. What is the ratio of the Balance of Payment (as % of service exports) in South Asia in 2007 to that in 2009?
Keep it short and to the point. 1.05. What is the ratio of the Balance of Payment (as % of service exports) in Belarus in 2007 to that in 2009?
Offer a terse response. 0.92. What is the ratio of the Balance of Payment (as % of service exports) of Guinea-Bissau in 2007 to that in 2009?
Give a very brief answer. 2.35. What is the ratio of the Balance of Payment (as % of service exports) in Libya in 2007 to that in 2009?
Your answer should be very brief. 5.27. What is the ratio of the Balance of Payment (as % of service exports) of South Asia in 2007 to that in 2010?
Your response must be concise. 1.05. What is the ratio of the Balance of Payment (as % of service exports) in Guinea-Bissau in 2007 to that in 2010?
Your response must be concise. 2.82. What is the ratio of the Balance of Payment (as % of service exports) of Libya in 2007 to that in 2010?
Provide a short and direct response. 4.67. What is the ratio of the Balance of Payment (as % of service exports) in South Asia in 2008 to that in 2009?
Provide a succinct answer. 0.94. What is the ratio of the Balance of Payment (as % of service exports) of Belarus in 2008 to that in 2009?
Make the answer very short. 0.79. What is the ratio of the Balance of Payment (as % of service exports) in Guinea-Bissau in 2008 to that in 2009?
Offer a very short reply. 2.41. What is the ratio of the Balance of Payment (as % of service exports) in Libya in 2008 to that in 2009?
Your answer should be compact. 2.75. What is the ratio of the Balance of Payment (as % of service exports) in South Asia in 2008 to that in 2010?
Provide a short and direct response. 0.94. What is the ratio of the Balance of Payment (as % of service exports) of Belarus in 2008 to that in 2010?
Provide a short and direct response. 0.86. What is the ratio of the Balance of Payment (as % of service exports) in Guinea-Bissau in 2008 to that in 2010?
Your answer should be compact. 2.89. What is the ratio of the Balance of Payment (as % of service exports) in Libya in 2008 to that in 2010?
Give a very brief answer. 2.44. What is the ratio of the Balance of Payment (as % of service exports) of South Asia in 2009 to that in 2010?
Your response must be concise. 1. What is the ratio of the Balance of Payment (as % of service exports) of Belarus in 2009 to that in 2010?
Offer a terse response. 1.08. What is the ratio of the Balance of Payment (as % of service exports) of Guinea-Bissau in 2009 to that in 2010?
Give a very brief answer. 1.2. What is the ratio of the Balance of Payment (as % of service exports) of Libya in 2009 to that in 2010?
Give a very brief answer. 0.89. What is the difference between the highest and the second highest Balance of Payment (as % of service exports) of South Asia?
Ensure brevity in your answer.  0.69. What is the difference between the highest and the second highest Balance of Payment (as % of service exports) in Belarus?
Provide a short and direct response. 0.1. What is the difference between the highest and the second highest Balance of Payment (as % of service exports) of Guinea-Bissau?
Give a very brief answer. 2.25. What is the difference between the highest and the second highest Balance of Payment (as % of service exports) of Libya?
Provide a succinct answer. 21.57. What is the difference between the highest and the lowest Balance of Payment (as % of service exports) in South Asia?
Your answer should be compact. 2.14. What is the difference between the highest and the lowest Balance of Payment (as % of service exports) in Belarus?
Make the answer very short. 2.9. What is the difference between the highest and the lowest Balance of Payment (as % of service exports) of Guinea-Bissau?
Provide a succinct answer. 57.11. What is the difference between the highest and the lowest Balance of Payment (as % of service exports) in Libya?
Make the answer very short. 55.4. 